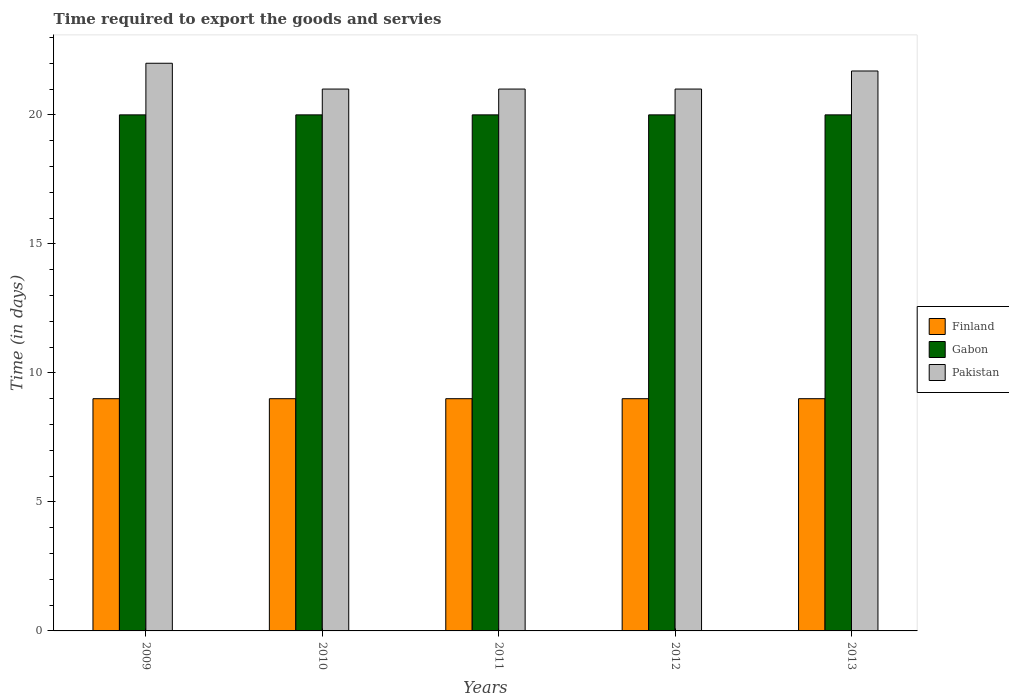Are the number of bars on each tick of the X-axis equal?
Keep it short and to the point. Yes. How many bars are there on the 5th tick from the left?
Provide a succinct answer. 3. In how many cases, is the number of bars for a given year not equal to the number of legend labels?
Offer a terse response. 0. What is the number of days required to export the goods and services in Gabon in 2010?
Give a very brief answer. 20. Across all years, what is the maximum number of days required to export the goods and services in Gabon?
Provide a succinct answer. 20. In which year was the number of days required to export the goods and services in Pakistan maximum?
Offer a terse response. 2009. What is the total number of days required to export the goods and services in Finland in the graph?
Keep it short and to the point. 45. What is the difference between the number of days required to export the goods and services in Pakistan in 2010 and that in 2013?
Offer a terse response. -0.7. In the year 2013, what is the difference between the number of days required to export the goods and services in Gabon and number of days required to export the goods and services in Finland?
Your response must be concise. 11. Is the difference between the number of days required to export the goods and services in Gabon in 2009 and 2012 greater than the difference between the number of days required to export the goods and services in Finland in 2009 and 2012?
Your answer should be compact. No. What is the difference between the highest and the second highest number of days required to export the goods and services in Finland?
Make the answer very short. 0. In how many years, is the number of days required to export the goods and services in Pakistan greater than the average number of days required to export the goods and services in Pakistan taken over all years?
Provide a succinct answer. 2. Is the sum of the number of days required to export the goods and services in Pakistan in 2009 and 2010 greater than the maximum number of days required to export the goods and services in Finland across all years?
Ensure brevity in your answer.  Yes. What does the 3rd bar from the left in 2010 represents?
Your response must be concise. Pakistan. What does the 1st bar from the right in 2009 represents?
Make the answer very short. Pakistan. How many bars are there?
Your answer should be very brief. 15. Does the graph contain grids?
Offer a very short reply. No. How many legend labels are there?
Provide a succinct answer. 3. How are the legend labels stacked?
Make the answer very short. Vertical. What is the title of the graph?
Make the answer very short. Time required to export the goods and servies. What is the label or title of the Y-axis?
Your response must be concise. Time (in days). What is the Time (in days) of Finland in 2009?
Provide a short and direct response. 9. What is the Time (in days) of Pakistan in 2010?
Your answer should be very brief. 21. What is the Time (in days) of Finland in 2012?
Your response must be concise. 9. What is the Time (in days) in Gabon in 2012?
Provide a succinct answer. 20. What is the Time (in days) in Pakistan in 2012?
Keep it short and to the point. 21. What is the Time (in days) in Pakistan in 2013?
Make the answer very short. 21.7. Across all years, what is the maximum Time (in days) in Finland?
Give a very brief answer. 9. Across all years, what is the maximum Time (in days) in Pakistan?
Ensure brevity in your answer.  22. Across all years, what is the minimum Time (in days) of Pakistan?
Keep it short and to the point. 21. What is the total Time (in days) in Finland in the graph?
Ensure brevity in your answer.  45. What is the total Time (in days) of Gabon in the graph?
Give a very brief answer. 100. What is the total Time (in days) in Pakistan in the graph?
Your response must be concise. 106.7. What is the difference between the Time (in days) of Gabon in 2009 and that in 2010?
Offer a terse response. 0. What is the difference between the Time (in days) in Pakistan in 2009 and that in 2010?
Your answer should be compact. 1. What is the difference between the Time (in days) of Finland in 2009 and that in 2011?
Your answer should be compact. 0. What is the difference between the Time (in days) in Gabon in 2009 and that in 2011?
Your answer should be compact. 0. What is the difference between the Time (in days) in Pakistan in 2009 and that in 2011?
Your response must be concise. 1. What is the difference between the Time (in days) in Finland in 2009 and that in 2012?
Give a very brief answer. 0. What is the difference between the Time (in days) in Gabon in 2009 and that in 2012?
Your answer should be very brief. 0. What is the difference between the Time (in days) of Finland in 2009 and that in 2013?
Make the answer very short. 0. What is the difference between the Time (in days) in Pakistan in 2009 and that in 2013?
Ensure brevity in your answer.  0.3. What is the difference between the Time (in days) in Finland in 2010 and that in 2011?
Offer a terse response. 0. What is the difference between the Time (in days) of Gabon in 2010 and that in 2011?
Ensure brevity in your answer.  0. What is the difference between the Time (in days) of Finland in 2010 and that in 2012?
Your response must be concise. 0. What is the difference between the Time (in days) of Gabon in 2010 and that in 2012?
Provide a succinct answer. 0. What is the difference between the Time (in days) of Gabon in 2010 and that in 2013?
Provide a short and direct response. 0. What is the difference between the Time (in days) of Pakistan in 2010 and that in 2013?
Make the answer very short. -0.7. What is the difference between the Time (in days) of Finland in 2011 and that in 2012?
Your response must be concise. 0. What is the difference between the Time (in days) in Gabon in 2011 and that in 2012?
Provide a succinct answer. 0. What is the difference between the Time (in days) in Pakistan in 2011 and that in 2012?
Provide a succinct answer. 0. What is the difference between the Time (in days) of Pakistan in 2011 and that in 2013?
Your response must be concise. -0.7. What is the difference between the Time (in days) of Finland in 2009 and the Time (in days) of Gabon in 2010?
Your response must be concise. -11. What is the difference between the Time (in days) of Finland in 2009 and the Time (in days) of Pakistan in 2010?
Offer a terse response. -12. What is the difference between the Time (in days) in Gabon in 2009 and the Time (in days) in Pakistan in 2010?
Offer a very short reply. -1. What is the difference between the Time (in days) of Finland in 2009 and the Time (in days) of Pakistan in 2011?
Provide a short and direct response. -12. What is the difference between the Time (in days) in Finland in 2009 and the Time (in days) in Pakistan in 2012?
Make the answer very short. -12. What is the difference between the Time (in days) in Finland in 2009 and the Time (in days) in Gabon in 2013?
Your answer should be compact. -11. What is the difference between the Time (in days) in Finland in 2009 and the Time (in days) in Pakistan in 2013?
Offer a terse response. -12.7. What is the difference between the Time (in days) in Gabon in 2009 and the Time (in days) in Pakistan in 2013?
Ensure brevity in your answer.  -1.7. What is the difference between the Time (in days) of Finland in 2010 and the Time (in days) of Pakistan in 2011?
Offer a very short reply. -12. What is the difference between the Time (in days) in Gabon in 2010 and the Time (in days) in Pakistan in 2011?
Your answer should be very brief. -1. What is the difference between the Time (in days) in Finland in 2010 and the Time (in days) in Pakistan in 2012?
Your answer should be compact. -12. What is the difference between the Time (in days) of Gabon in 2010 and the Time (in days) of Pakistan in 2012?
Offer a terse response. -1. What is the difference between the Time (in days) in Gabon in 2010 and the Time (in days) in Pakistan in 2013?
Keep it short and to the point. -1.7. What is the difference between the Time (in days) of Finland in 2011 and the Time (in days) of Pakistan in 2012?
Give a very brief answer. -12. What is the difference between the Time (in days) of Finland in 2011 and the Time (in days) of Pakistan in 2013?
Make the answer very short. -12.7. What is the difference between the Time (in days) in Gabon in 2011 and the Time (in days) in Pakistan in 2013?
Make the answer very short. -1.7. What is the difference between the Time (in days) of Finland in 2012 and the Time (in days) of Pakistan in 2013?
Your answer should be compact. -12.7. What is the average Time (in days) in Pakistan per year?
Offer a terse response. 21.34. In the year 2009, what is the difference between the Time (in days) in Finland and Time (in days) in Gabon?
Your response must be concise. -11. In the year 2009, what is the difference between the Time (in days) of Gabon and Time (in days) of Pakistan?
Ensure brevity in your answer.  -2. In the year 2010, what is the difference between the Time (in days) in Finland and Time (in days) in Pakistan?
Keep it short and to the point. -12. In the year 2011, what is the difference between the Time (in days) in Gabon and Time (in days) in Pakistan?
Provide a short and direct response. -1. In the year 2012, what is the difference between the Time (in days) of Finland and Time (in days) of Gabon?
Keep it short and to the point. -11. In the year 2012, what is the difference between the Time (in days) of Finland and Time (in days) of Pakistan?
Provide a succinct answer. -12. In the year 2012, what is the difference between the Time (in days) of Gabon and Time (in days) of Pakistan?
Offer a terse response. -1. In the year 2013, what is the difference between the Time (in days) in Finland and Time (in days) in Gabon?
Your response must be concise. -11. In the year 2013, what is the difference between the Time (in days) of Gabon and Time (in days) of Pakistan?
Make the answer very short. -1.7. What is the ratio of the Time (in days) of Finland in 2009 to that in 2010?
Offer a very short reply. 1. What is the ratio of the Time (in days) in Pakistan in 2009 to that in 2010?
Give a very brief answer. 1.05. What is the ratio of the Time (in days) of Pakistan in 2009 to that in 2011?
Provide a succinct answer. 1.05. What is the ratio of the Time (in days) in Finland in 2009 to that in 2012?
Keep it short and to the point. 1. What is the ratio of the Time (in days) of Gabon in 2009 to that in 2012?
Give a very brief answer. 1. What is the ratio of the Time (in days) in Pakistan in 2009 to that in 2012?
Provide a short and direct response. 1.05. What is the ratio of the Time (in days) in Finland in 2009 to that in 2013?
Keep it short and to the point. 1. What is the ratio of the Time (in days) of Gabon in 2009 to that in 2013?
Offer a terse response. 1. What is the ratio of the Time (in days) of Pakistan in 2009 to that in 2013?
Offer a very short reply. 1.01. What is the ratio of the Time (in days) in Finland in 2010 to that in 2011?
Offer a very short reply. 1. What is the ratio of the Time (in days) of Gabon in 2010 to that in 2011?
Your answer should be compact. 1. What is the ratio of the Time (in days) in Pakistan in 2010 to that in 2011?
Your answer should be very brief. 1. What is the ratio of the Time (in days) in Finland in 2010 to that in 2012?
Give a very brief answer. 1. What is the ratio of the Time (in days) in Pakistan in 2010 to that in 2012?
Give a very brief answer. 1. What is the ratio of the Time (in days) in Gabon in 2010 to that in 2013?
Your answer should be compact. 1. What is the ratio of the Time (in days) of Finland in 2011 to that in 2013?
Make the answer very short. 1. What is the ratio of the Time (in days) of Pakistan in 2011 to that in 2013?
Your answer should be compact. 0.97. What is the ratio of the Time (in days) in Gabon in 2012 to that in 2013?
Make the answer very short. 1. What is the ratio of the Time (in days) in Pakistan in 2012 to that in 2013?
Ensure brevity in your answer.  0.97. What is the difference between the highest and the second highest Time (in days) in Finland?
Your response must be concise. 0. What is the difference between the highest and the second highest Time (in days) of Gabon?
Ensure brevity in your answer.  0. What is the difference between the highest and the second highest Time (in days) of Pakistan?
Your response must be concise. 0.3. What is the difference between the highest and the lowest Time (in days) of Finland?
Ensure brevity in your answer.  0. What is the difference between the highest and the lowest Time (in days) in Pakistan?
Provide a succinct answer. 1. 